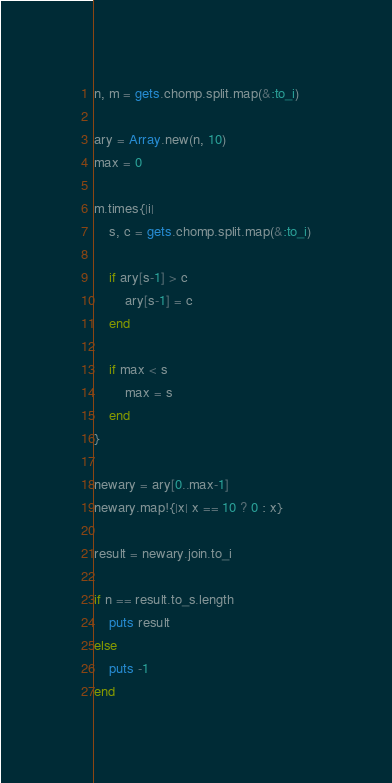Convert code to text. <code><loc_0><loc_0><loc_500><loc_500><_Ruby_>n, m = gets.chomp.split.map(&:to_i)

ary = Array.new(n, 10)
max = 0

m.times{|i|
    s, c = gets.chomp.split.map(&:to_i)

    if ary[s-1] > c
        ary[s-1] = c
    end

    if max < s
        max = s
    end
}

newary = ary[0..max-1]
newary.map!{|x| x == 10 ? 0 : x}

result = newary.join.to_i

if n == result.to_s.length
    puts result
else
    puts -1
end</code> 